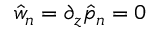Convert formula to latex. <formula><loc_0><loc_0><loc_500><loc_500>\hat { w } _ { n } = \partial _ { z } \hat { p } _ { n } = 0</formula> 